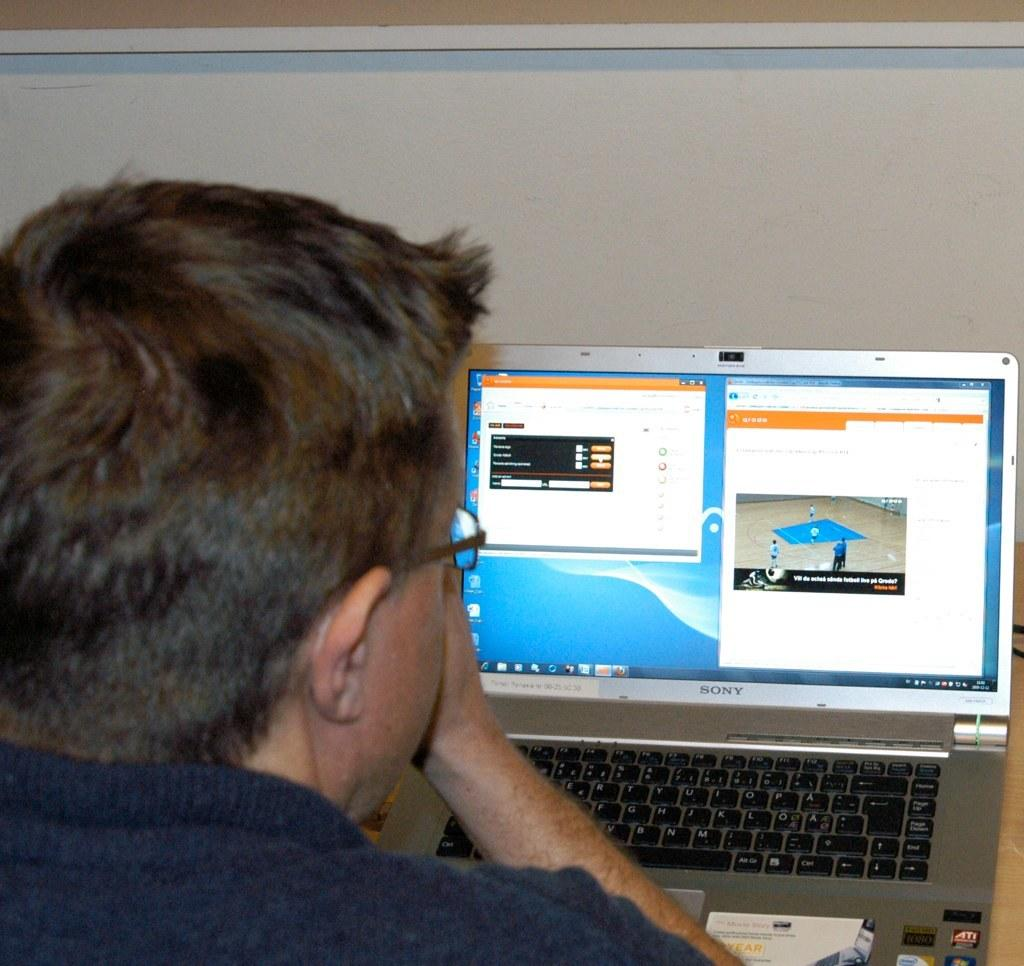Provide a one-sentence caption for the provided image. A man looks at the screen of a  Sony laptop which has a Firefox browser open. 